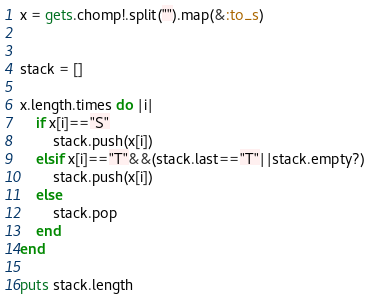<code> <loc_0><loc_0><loc_500><loc_500><_Ruby_>
x = gets.chomp!.split("").map(&:to_s)


stack = []

x.length.times do |i|
	if x[i]=="S"
		stack.push(x[i])
	elsif x[i]=="T"&&(stack.last=="T"||stack.empty?)
		stack.push(x[i])
	else
		stack.pop
	end
end

puts stack.length


</code> 